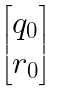<formula> <loc_0><loc_0><loc_500><loc_500>\begin{bmatrix} q _ { 0 } \\ r _ { 0 } \end{bmatrix}</formula> 